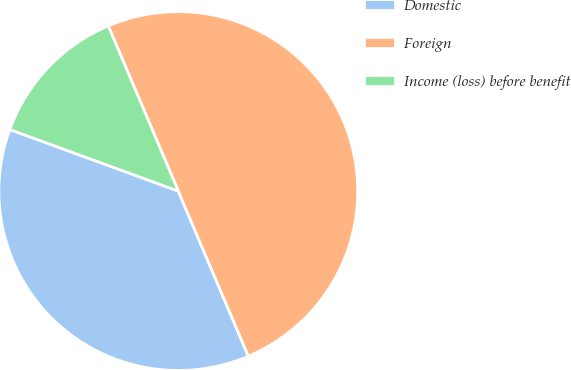Convert chart. <chart><loc_0><loc_0><loc_500><loc_500><pie_chart><fcel>Domestic<fcel>Foreign<fcel>Income (loss) before benefit<nl><fcel>36.96%<fcel>50.0%<fcel>13.04%<nl></chart> 